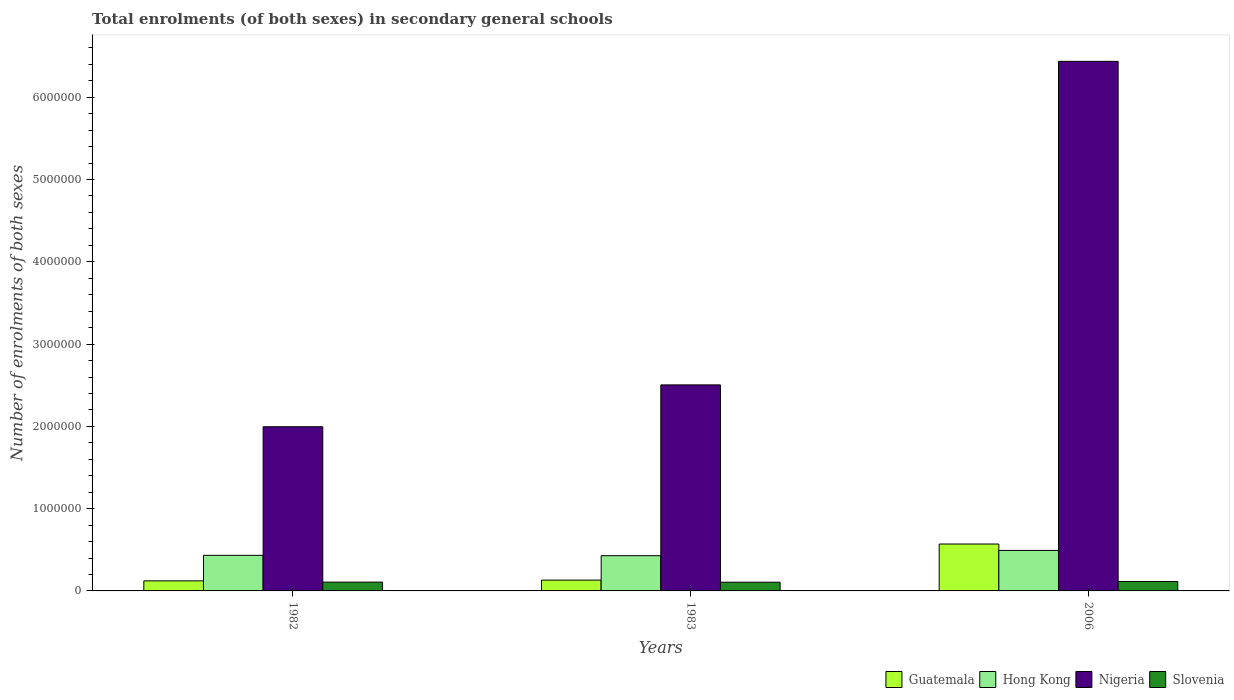How many groups of bars are there?
Your answer should be compact. 3. How many bars are there on the 3rd tick from the right?
Provide a succinct answer. 4. What is the number of enrolments in secondary schools in Hong Kong in 1983?
Give a very brief answer. 4.28e+05. Across all years, what is the maximum number of enrolments in secondary schools in Hong Kong?
Your answer should be compact. 4.92e+05. Across all years, what is the minimum number of enrolments in secondary schools in Hong Kong?
Offer a terse response. 4.28e+05. In which year was the number of enrolments in secondary schools in Slovenia maximum?
Offer a very short reply. 2006. In which year was the number of enrolments in secondary schools in Nigeria minimum?
Provide a short and direct response. 1982. What is the total number of enrolments in secondary schools in Hong Kong in the graph?
Provide a succinct answer. 1.35e+06. What is the difference between the number of enrolments in secondary schools in Slovenia in 1982 and that in 2006?
Ensure brevity in your answer.  -7749. What is the difference between the number of enrolments in secondary schools in Slovenia in 1982 and the number of enrolments in secondary schools in Nigeria in 2006?
Provide a short and direct response. -6.33e+06. What is the average number of enrolments in secondary schools in Nigeria per year?
Give a very brief answer. 3.65e+06. In the year 1983, what is the difference between the number of enrolments in secondary schools in Nigeria and number of enrolments in secondary schools in Slovenia?
Make the answer very short. 2.40e+06. What is the ratio of the number of enrolments in secondary schools in Slovenia in 1982 to that in 1983?
Offer a terse response. 1.01. Is the number of enrolments in secondary schools in Guatemala in 1982 less than that in 1983?
Offer a terse response. Yes. What is the difference between the highest and the second highest number of enrolments in secondary schools in Guatemala?
Offer a very short reply. 4.39e+05. What is the difference between the highest and the lowest number of enrolments in secondary schools in Nigeria?
Ensure brevity in your answer.  4.44e+06. Is the sum of the number of enrolments in secondary schools in Guatemala in 1982 and 2006 greater than the maximum number of enrolments in secondary schools in Slovenia across all years?
Provide a short and direct response. Yes. What does the 2nd bar from the left in 1982 represents?
Give a very brief answer. Hong Kong. What does the 1st bar from the right in 2006 represents?
Your answer should be very brief. Slovenia. Is it the case that in every year, the sum of the number of enrolments in secondary schools in Hong Kong and number of enrolments in secondary schools in Nigeria is greater than the number of enrolments in secondary schools in Guatemala?
Your response must be concise. Yes. How many bars are there?
Provide a succinct answer. 12. Are all the bars in the graph horizontal?
Provide a short and direct response. No. What is the difference between two consecutive major ticks on the Y-axis?
Your response must be concise. 1.00e+06. Does the graph contain grids?
Give a very brief answer. No. What is the title of the graph?
Give a very brief answer. Total enrolments (of both sexes) in secondary general schools. What is the label or title of the Y-axis?
Make the answer very short. Number of enrolments of both sexes. What is the Number of enrolments of both sexes in Guatemala in 1982?
Offer a terse response. 1.22e+05. What is the Number of enrolments of both sexes of Hong Kong in 1982?
Your answer should be very brief. 4.32e+05. What is the Number of enrolments of both sexes of Nigeria in 1982?
Give a very brief answer. 2.00e+06. What is the Number of enrolments of both sexes of Slovenia in 1982?
Provide a succinct answer. 1.07e+05. What is the Number of enrolments of both sexes in Guatemala in 1983?
Make the answer very short. 1.31e+05. What is the Number of enrolments of both sexes in Hong Kong in 1983?
Keep it short and to the point. 4.28e+05. What is the Number of enrolments of both sexes of Nigeria in 1983?
Provide a short and direct response. 2.50e+06. What is the Number of enrolments of both sexes in Slovenia in 1983?
Keep it short and to the point. 1.06e+05. What is the Number of enrolments of both sexes in Guatemala in 2006?
Give a very brief answer. 5.70e+05. What is the Number of enrolments of both sexes of Hong Kong in 2006?
Offer a very short reply. 4.92e+05. What is the Number of enrolments of both sexes in Nigeria in 2006?
Offer a very short reply. 6.44e+06. What is the Number of enrolments of both sexes of Slovenia in 2006?
Your answer should be compact. 1.15e+05. Across all years, what is the maximum Number of enrolments of both sexes of Guatemala?
Your response must be concise. 5.70e+05. Across all years, what is the maximum Number of enrolments of both sexes of Hong Kong?
Your response must be concise. 4.92e+05. Across all years, what is the maximum Number of enrolments of both sexes of Nigeria?
Provide a short and direct response. 6.44e+06. Across all years, what is the maximum Number of enrolments of both sexes in Slovenia?
Provide a succinct answer. 1.15e+05. Across all years, what is the minimum Number of enrolments of both sexes of Guatemala?
Offer a very short reply. 1.22e+05. Across all years, what is the minimum Number of enrolments of both sexes in Hong Kong?
Offer a very short reply. 4.28e+05. Across all years, what is the minimum Number of enrolments of both sexes of Nigeria?
Ensure brevity in your answer.  2.00e+06. Across all years, what is the minimum Number of enrolments of both sexes in Slovenia?
Your response must be concise. 1.06e+05. What is the total Number of enrolments of both sexes in Guatemala in the graph?
Make the answer very short. 8.24e+05. What is the total Number of enrolments of both sexes of Hong Kong in the graph?
Keep it short and to the point. 1.35e+06. What is the total Number of enrolments of both sexes of Nigeria in the graph?
Keep it short and to the point. 1.09e+07. What is the total Number of enrolments of both sexes in Slovenia in the graph?
Your answer should be compact. 3.28e+05. What is the difference between the Number of enrolments of both sexes in Guatemala in 1982 and that in 1983?
Provide a short and direct response. -8915. What is the difference between the Number of enrolments of both sexes in Hong Kong in 1982 and that in 1983?
Make the answer very short. 4314. What is the difference between the Number of enrolments of both sexes of Nigeria in 1982 and that in 1983?
Give a very brief answer. -5.09e+05. What is the difference between the Number of enrolments of both sexes in Slovenia in 1982 and that in 1983?
Provide a succinct answer. 1093. What is the difference between the Number of enrolments of both sexes in Guatemala in 1982 and that in 2006?
Make the answer very short. -4.48e+05. What is the difference between the Number of enrolments of both sexes of Hong Kong in 1982 and that in 2006?
Your response must be concise. -5.95e+04. What is the difference between the Number of enrolments of both sexes in Nigeria in 1982 and that in 2006?
Provide a succinct answer. -4.44e+06. What is the difference between the Number of enrolments of both sexes of Slovenia in 1982 and that in 2006?
Make the answer very short. -7749. What is the difference between the Number of enrolments of both sexes of Guatemala in 1983 and that in 2006?
Offer a very short reply. -4.39e+05. What is the difference between the Number of enrolments of both sexes in Hong Kong in 1983 and that in 2006?
Give a very brief answer. -6.38e+04. What is the difference between the Number of enrolments of both sexes in Nigeria in 1983 and that in 2006?
Provide a short and direct response. -3.93e+06. What is the difference between the Number of enrolments of both sexes of Slovenia in 1983 and that in 2006?
Your answer should be very brief. -8842. What is the difference between the Number of enrolments of both sexes in Guatemala in 1982 and the Number of enrolments of both sexes in Hong Kong in 1983?
Provide a succinct answer. -3.06e+05. What is the difference between the Number of enrolments of both sexes in Guatemala in 1982 and the Number of enrolments of both sexes in Nigeria in 1983?
Keep it short and to the point. -2.38e+06. What is the difference between the Number of enrolments of both sexes of Guatemala in 1982 and the Number of enrolments of both sexes of Slovenia in 1983?
Your answer should be compact. 1.65e+04. What is the difference between the Number of enrolments of both sexes in Hong Kong in 1982 and the Number of enrolments of both sexes in Nigeria in 1983?
Your response must be concise. -2.07e+06. What is the difference between the Number of enrolments of both sexes in Hong Kong in 1982 and the Number of enrolments of both sexes in Slovenia in 1983?
Offer a very short reply. 3.27e+05. What is the difference between the Number of enrolments of both sexes of Nigeria in 1982 and the Number of enrolments of both sexes of Slovenia in 1983?
Provide a short and direct response. 1.89e+06. What is the difference between the Number of enrolments of both sexes in Guatemala in 1982 and the Number of enrolments of both sexes in Hong Kong in 2006?
Your response must be concise. -3.70e+05. What is the difference between the Number of enrolments of both sexes of Guatemala in 1982 and the Number of enrolments of both sexes of Nigeria in 2006?
Make the answer very short. -6.31e+06. What is the difference between the Number of enrolments of both sexes of Guatemala in 1982 and the Number of enrolments of both sexes of Slovenia in 2006?
Provide a short and direct response. 7630. What is the difference between the Number of enrolments of both sexes in Hong Kong in 1982 and the Number of enrolments of both sexes in Nigeria in 2006?
Keep it short and to the point. -6.00e+06. What is the difference between the Number of enrolments of both sexes of Hong Kong in 1982 and the Number of enrolments of both sexes of Slovenia in 2006?
Your answer should be compact. 3.18e+05. What is the difference between the Number of enrolments of both sexes of Nigeria in 1982 and the Number of enrolments of both sexes of Slovenia in 2006?
Provide a short and direct response. 1.88e+06. What is the difference between the Number of enrolments of both sexes of Guatemala in 1983 and the Number of enrolments of both sexes of Hong Kong in 2006?
Offer a very short reply. -3.61e+05. What is the difference between the Number of enrolments of both sexes of Guatemala in 1983 and the Number of enrolments of both sexes of Nigeria in 2006?
Make the answer very short. -6.31e+06. What is the difference between the Number of enrolments of both sexes in Guatemala in 1983 and the Number of enrolments of both sexes in Slovenia in 2006?
Your answer should be very brief. 1.65e+04. What is the difference between the Number of enrolments of both sexes in Hong Kong in 1983 and the Number of enrolments of both sexes in Nigeria in 2006?
Make the answer very short. -6.01e+06. What is the difference between the Number of enrolments of both sexes in Hong Kong in 1983 and the Number of enrolments of both sexes in Slovenia in 2006?
Provide a succinct answer. 3.13e+05. What is the difference between the Number of enrolments of both sexes in Nigeria in 1983 and the Number of enrolments of both sexes in Slovenia in 2006?
Keep it short and to the point. 2.39e+06. What is the average Number of enrolments of both sexes of Guatemala per year?
Make the answer very short. 2.75e+05. What is the average Number of enrolments of both sexes of Hong Kong per year?
Your response must be concise. 4.51e+05. What is the average Number of enrolments of both sexes in Nigeria per year?
Give a very brief answer. 3.65e+06. What is the average Number of enrolments of both sexes in Slovenia per year?
Ensure brevity in your answer.  1.09e+05. In the year 1982, what is the difference between the Number of enrolments of both sexes in Guatemala and Number of enrolments of both sexes in Hong Kong?
Provide a short and direct response. -3.10e+05. In the year 1982, what is the difference between the Number of enrolments of both sexes in Guatemala and Number of enrolments of both sexes in Nigeria?
Ensure brevity in your answer.  -1.87e+06. In the year 1982, what is the difference between the Number of enrolments of both sexes of Guatemala and Number of enrolments of both sexes of Slovenia?
Keep it short and to the point. 1.54e+04. In the year 1982, what is the difference between the Number of enrolments of both sexes of Hong Kong and Number of enrolments of both sexes of Nigeria?
Offer a terse response. -1.56e+06. In the year 1982, what is the difference between the Number of enrolments of both sexes in Hong Kong and Number of enrolments of both sexes in Slovenia?
Offer a very short reply. 3.25e+05. In the year 1982, what is the difference between the Number of enrolments of both sexes in Nigeria and Number of enrolments of both sexes in Slovenia?
Ensure brevity in your answer.  1.89e+06. In the year 1983, what is the difference between the Number of enrolments of both sexes of Guatemala and Number of enrolments of both sexes of Hong Kong?
Your response must be concise. -2.97e+05. In the year 1983, what is the difference between the Number of enrolments of both sexes of Guatemala and Number of enrolments of both sexes of Nigeria?
Offer a very short reply. -2.37e+06. In the year 1983, what is the difference between the Number of enrolments of both sexes in Guatemala and Number of enrolments of both sexes in Slovenia?
Ensure brevity in your answer.  2.54e+04. In the year 1983, what is the difference between the Number of enrolments of both sexes of Hong Kong and Number of enrolments of both sexes of Nigeria?
Your answer should be compact. -2.08e+06. In the year 1983, what is the difference between the Number of enrolments of both sexes in Hong Kong and Number of enrolments of both sexes in Slovenia?
Your response must be concise. 3.22e+05. In the year 1983, what is the difference between the Number of enrolments of both sexes of Nigeria and Number of enrolments of both sexes of Slovenia?
Offer a very short reply. 2.40e+06. In the year 2006, what is the difference between the Number of enrolments of both sexes in Guatemala and Number of enrolments of both sexes in Hong Kong?
Offer a terse response. 7.81e+04. In the year 2006, what is the difference between the Number of enrolments of both sexes in Guatemala and Number of enrolments of both sexes in Nigeria?
Keep it short and to the point. -5.87e+06. In the year 2006, what is the difference between the Number of enrolments of both sexes of Guatemala and Number of enrolments of both sexes of Slovenia?
Your answer should be compact. 4.55e+05. In the year 2006, what is the difference between the Number of enrolments of both sexes in Hong Kong and Number of enrolments of both sexes in Nigeria?
Provide a short and direct response. -5.94e+06. In the year 2006, what is the difference between the Number of enrolments of both sexes in Hong Kong and Number of enrolments of both sexes in Slovenia?
Give a very brief answer. 3.77e+05. In the year 2006, what is the difference between the Number of enrolments of both sexes of Nigeria and Number of enrolments of both sexes of Slovenia?
Make the answer very short. 6.32e+06. What is the ratio of the Number of enrolments of both sexes of Guatemala in 1982 to that in 1983?
Give a very brief answer. 0.93. What is the ratio of the Number of enrolments of both sexes in Hong Kong in 1982 to that in 1983?
Your response must be concise. 1.01. What is the ratio of the Number of enrolments of both sexes of Nigeria in 1982 to that in 1983?
Your answer should be very brief. 0.8. What is the ratio of the Number of enrolments of both sexes of Slovenia in 1982 to that in 1983?
Ensure brevity in your answer.  1.01. What is the ratio of the Number of enrolments of both sexes of Guatemala in 1982 to that in 2006?
Offer a terse response. 0.21. What is the ratio of the Number of enrolments of both sexes in Hong Kong in 1982 to that in 2006?
Your answer should be compact. 0.88. What is the ratio of the Number of enrolments of both sexes of Nigeria in 1982 to that in 2006?
Your answer should be compact. 0.31. What is the ratio of the Number of enrolments of both sexes in Slovenia in 1982 to that in 2006?
Your response must be concise. 0.93. What is the ratio of the Number of enrolments of both sexes in Guatemala in 1983 to that in 2006?
Make the answer very short. 0.23. What is the ratio of the Number of enrolments of both sexes of Hong Kong in 1983 to that in 2006?
Ensure brevity in your answer.  0.87. What is the ratio of the Number of enrolments of both sexes in Nigeria in 1983 to that in 2006?
Keep it short and to the point. 0.39. What is the ratio of the Number of enrolments of both sexes in Slovenia in 1983 to that in 2006?
Give a very brief answer. 0.92. What is the difference between the highest and the second highest Number of enrolments of both sexes of Guatemala?
Your response must be concise. 4.39e+05. What is the difference between the highest and the second highest Number of enrolments of both sexes in Hong Kong?
Your response must be concise. 5.95e+04. What is the difference between the highest and the second highest Number of enrolments of both sexes in Nigeria?
Ensure brevity in your answer.  3.93e+06. What is the difference between the highest and the second highest Number of enrolments of both sexes in Slovenia?
Offer a terse response. 7749. What is the difference between the highest and the lowest Number of enrolments of both sexes in Guatemala?
Make the answer very short. 4.48e+05. What is the difference between the highest and the lowest Number of enrolments of both sexes of Hong Kong?
Provide a short and direct response. 6.38e+04. What is the difference between the highest and the lowest Number of enrolments of both sexes in Nigeria?
Provide a short and direct response. 4.44e+06. What is the difference between the highest and the lowest Number of enrolments of both sexes of Slovenia?
Make the answer very short. 8842. 